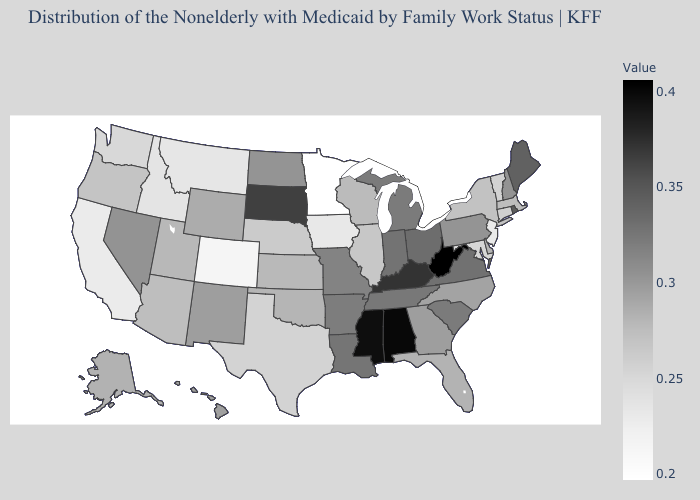Is the legend a continuous bar?
Keep it brief. Yes. Does Wisconsin have the lowest value in the MidWest?
Quick response, please. No. Does New Mexico have a lower value than Idaho?
Answer briefly. No. Which states hav the highest value in the South?
Be succinct. West Virginia. Does North Dakota have a lower value than Tennessee?
Concise answer only. Yes. Is the legend a continuous bar?
Answer briefly. Yes. Does Minnesota have the lowest value in the USA?
Quick response, please. Yes. 